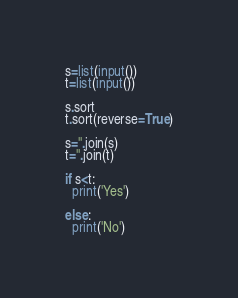Convert code to text. <code><loc_0><loc_0><loc_500><loc_500><_Python_>s=list(input())
t=list(input())

s.sort
t.sort(reverse=True)

s=''.join(s)
t=''.join(t)

if s<t:
  print('Yes')
  
else:
  print('No')</code> 